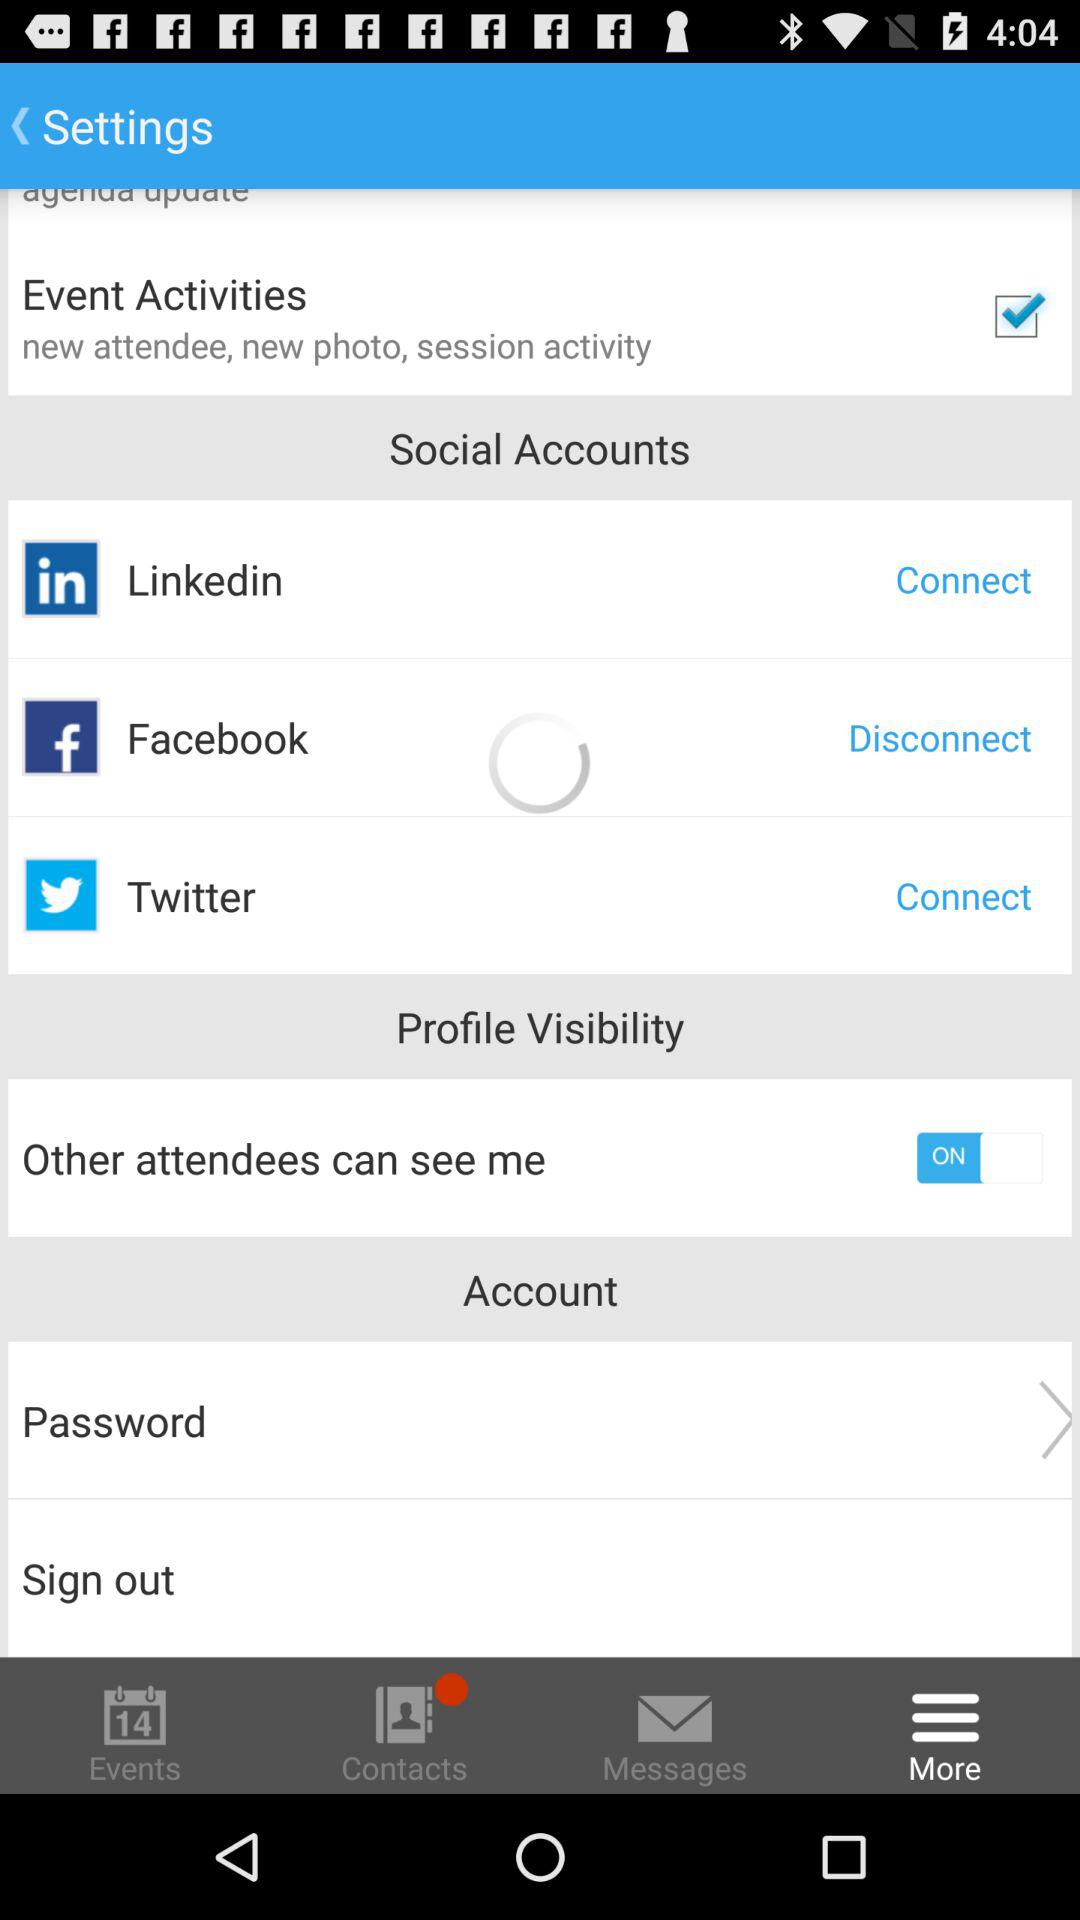How many social accounts are there?
Answer the question using a single word or phrase. 3 